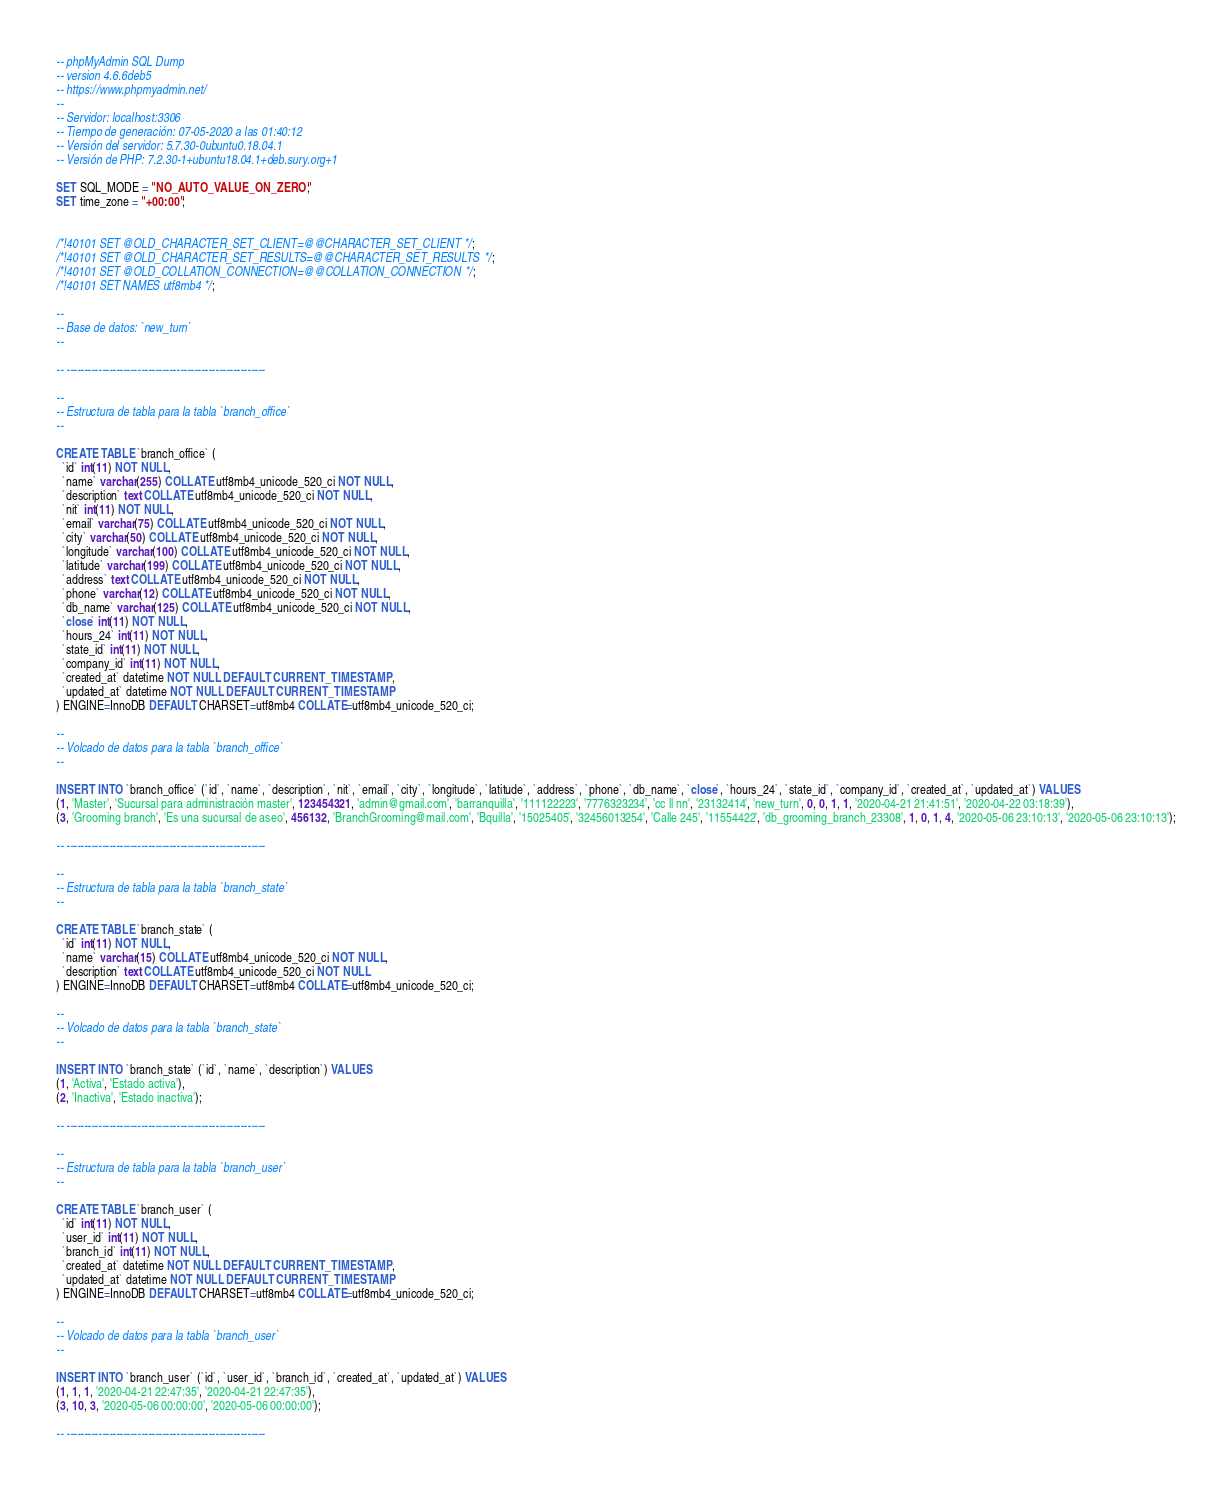Convert code to text. <code><loc_0><loc_0><loc_500><loc_500><_SQL_>-- phpMyAdmin SQL Dump
-- version 4.6.6deb5
-- https://www.phpmyadmin.net/
--
-- Servidor: localhost:3306
-- Tiempo de generación: 07-05-2020 a las 01:40:12
-- Versión del servidor: 5.7.30-0ubuntu0.18.04.1
-- Versión de PHP: 7.2.30-1+ubuntu18.04.1+deb.sury.org+1

SET SQL_MODE = "NO_AUTO_VALUE_ON_ZERO";
SET time_zone = "+00:00";


/*!40101 SET @OLD_CHARACTER_SET_CLIENT=@@CHARACTER_SET_CLIENT */;
/*!40101 SET @OLD_CHARACTER_SET_RESULTS=@@CHARACTER_SET_RESULTS */;
/*!40101 SET @OLD_COLLATION_CONNECTION=@@COLLATION_CONNECTION */;
/*!40101 SET NAMES utf8mb4 */;

--
-- Base de datos: `new_turn`
--

-- --------------------------------------------------------

--
-- Estructura de tabla para la tabla `branch_office`
--

CREATE TABLE `branch_office` (
  `id` int(11) NOT NULL,
  `name` varchar(255) COLLATE utf8mb4_unicode_520_ci NOT NULL,
  `description` text COLLATE utf8mb4_unicode_520_ci NOT NULL,
  `nit` int(11) NOT NULL,
  `email` varchar(75) COLLATE utf8mb4_unicode_520_ci NOT NULL,
  `city` varchar(50) COLLATE utf8mb4_unicode_520_ci NOT NULL,
  `longitude` varchar(100) COLLATE utf8mb4_unicode_520_ci NOT NULL,
  `latitude` varchar(199) COLLATE utf8mb4_unicode_520_ci NOT NULL,
  `address` text COLLATE utf8mb4_unicode_520_ci NOT NULL,
  `phone` varchar(12) COLLATE utf8mb4_unicode_520_ci NOT NULL,
  `db_name` varchar(125) COLLATE utf8mb4_unicode_520_ci NOT NULL,
  `close` int(11) NOT NULL,
  `hours_24` int(11) NOT NULL,
  `state_id` int(11) NOT NULL,
  `company_id` int(11) NOT NULL,
  `created_at` datetime NOT NULL DEFAULT CURRENT_TIMESTAMP,
  `updated_at` datetime NOT NULL DEFAULT CURRENT_TIMESTAMP
) ENGINE=InnoDB DEFAULT CHARSET=utf8mb4 COLLATE=utf8mb4_unicode_520_ci;

--
-- Volcado de datos para la tabla `branch_office`
--

INSERT INTO `branch_office` (`id`, `name`, `description`, `nit`, `email`, `city`, `longitude`, `latitude`, `address`, `phone`, `db_name`, `close`, `hours_24`, `state_id`, `company_id`, `created_at`, `updated_at`) VALUES
(1, 'Master', 'Sucursal para administración master', 123454321, 'admin@gmail.com', 'barranquilla', '111122223', '7776323234', 'cc ll nn', '23132414', 'new_turn', 0, 0, 1, 1, '2020-04-21 21:41:51', '2020-04-22 03:18:39'),
(3, 'Grooming branch', 'Es una sucursal de aseo', 456132, 'BranchGrooming@mail.com', 'Bquilla', '15025405', '32456013254', 'Calle 245', '11554422', 'db_grooming_branch_23308', 1, 0, 1, 4, '2020-05-06 23:10:13', '2020-05-06 23:10:13');

-- --------------------------------------------------------

--
-- Estructura de tabla para la tabla `branch_state`
--

CREATE TABLE `branch_state` (
  `id` int(11) NOT NULL,
  `name` varchar(15) COLLATE utf8mb4_unicode_520_ci NOT NULL,
  `description` text COLLATE utf8mb4_unicode_520_ci NOT NULL
) ENGINE=InnoDB DEFAULT CHARSET=utf8mb4 COLLATE=utf8mb4_unicode_520_ci;

--
-- Volcado de datos para la tabla `branch_state`
--

INSERT INTO `branch_state` (`id`, `name`, `description`) VALUES
(1, 'Activa', 'Estado activa'),
(2, 'Inactiva', 'Estado inactiva');

-- --------------------------------------------------------

--
-- Estructura de tabla para la tabla `branch_user`
--

CREATE TABLE `branch_user` (
  `id` int(11) NOT NULL,
  `user_id` int(11) NOT NULL,
  `branch_id` int(11) NOT NULL,
  `created_at` datetime NOT NULL DEFAULT CURRENT_TIMESTAMP,
  `updated_at` datetime NOT NULL DEFAULT CURRENT_TIMESTAMP
) ENGINE=InnoDB DEFAULT CHARSET=utf8mb4 COLLATE=utf8mb4_unicode_520_ci;

--
-- Volcado de datos para la tabla `branch_user`
--

INSERT INTO `branch_user` (`id`, `user_id`, `branch_id`, `created_at`, `updated_at`) VALUES
(1, 1, 1, '2020-04-21 22:47:35', '2020-04-21 22:47:35'),
(3, 10, 3, '2020-05-06 00:00:00', '2020-05-06 00:00:00');

-- --------------------------------------------------------
</code> 